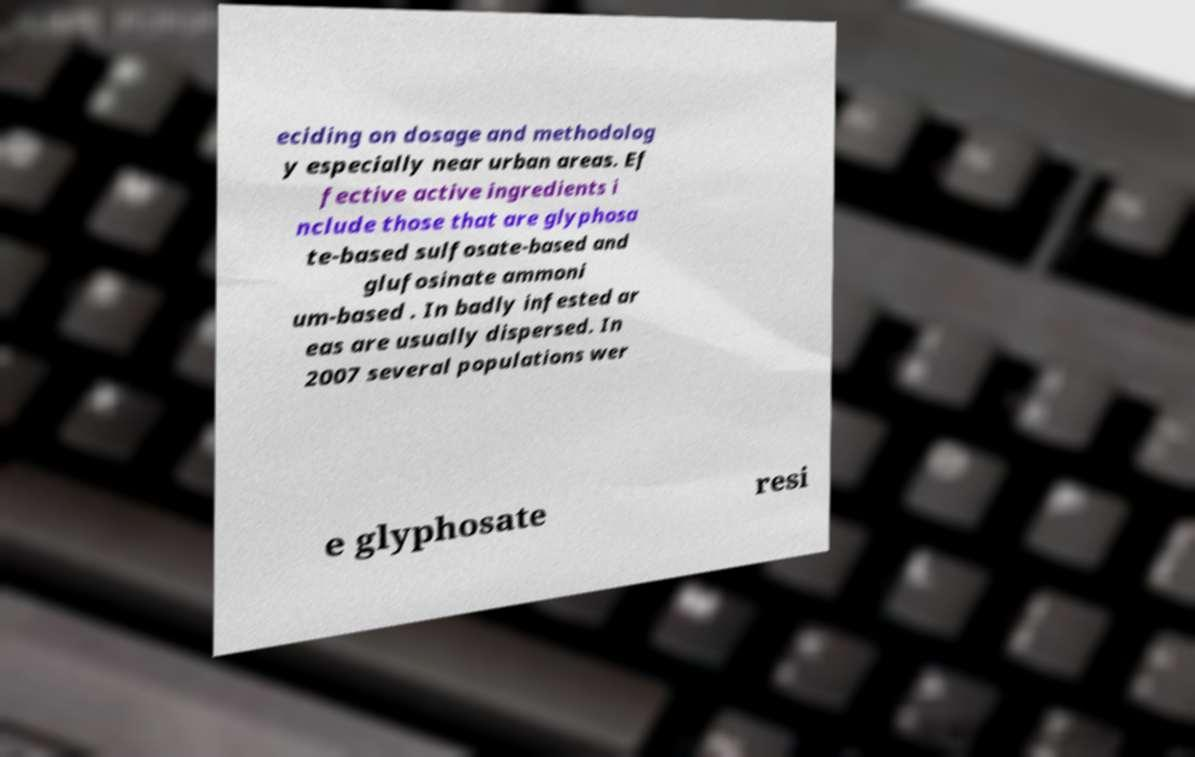Could you extract and type out the text from this image? eciding on dosage and methodolog y especially near urban areas. Ef fective active ingredients i nclude those that are glyphosa te-based sulfosate-based and glufosinate ammoni um-based . In badly infested ar eas are usually dispersed. In 2007 several populations wer e glyphosate resi 